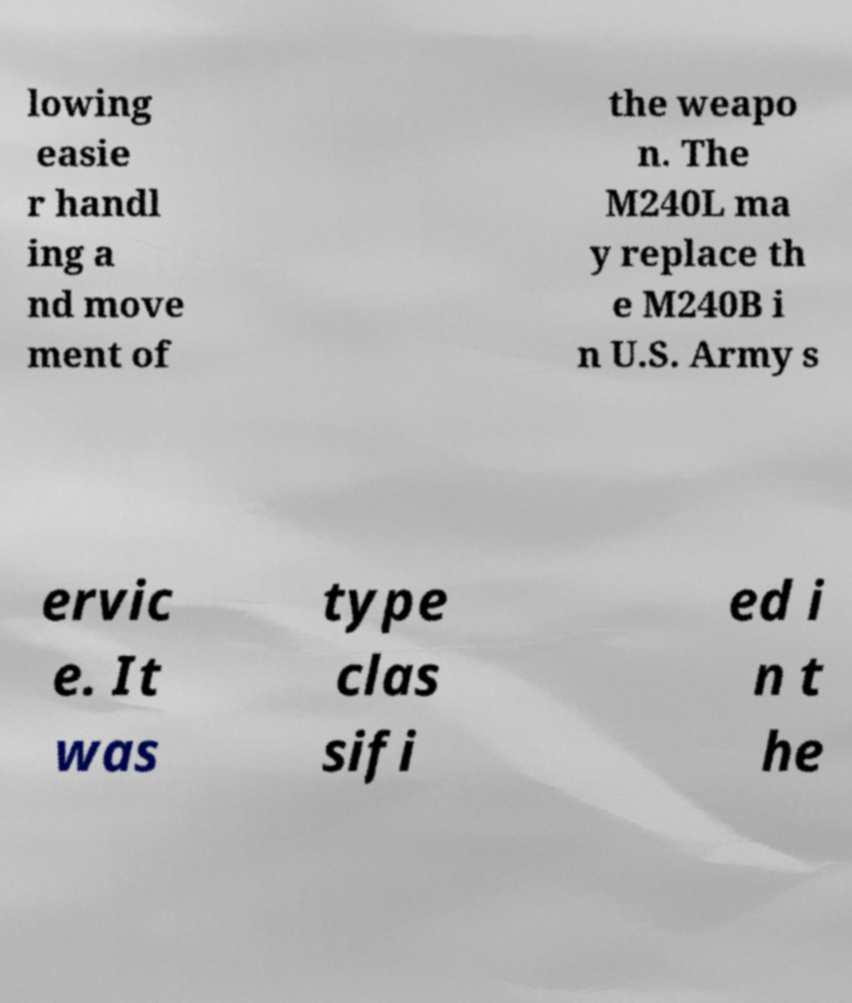Please read and relay the text visible in this image. What does it say? lowing easie r handl ing a nd move ment of the weapo n. The M240L ma y replace th e M240B i n U.S. Army s ervic e. It was type clas sifi ed i n t he 